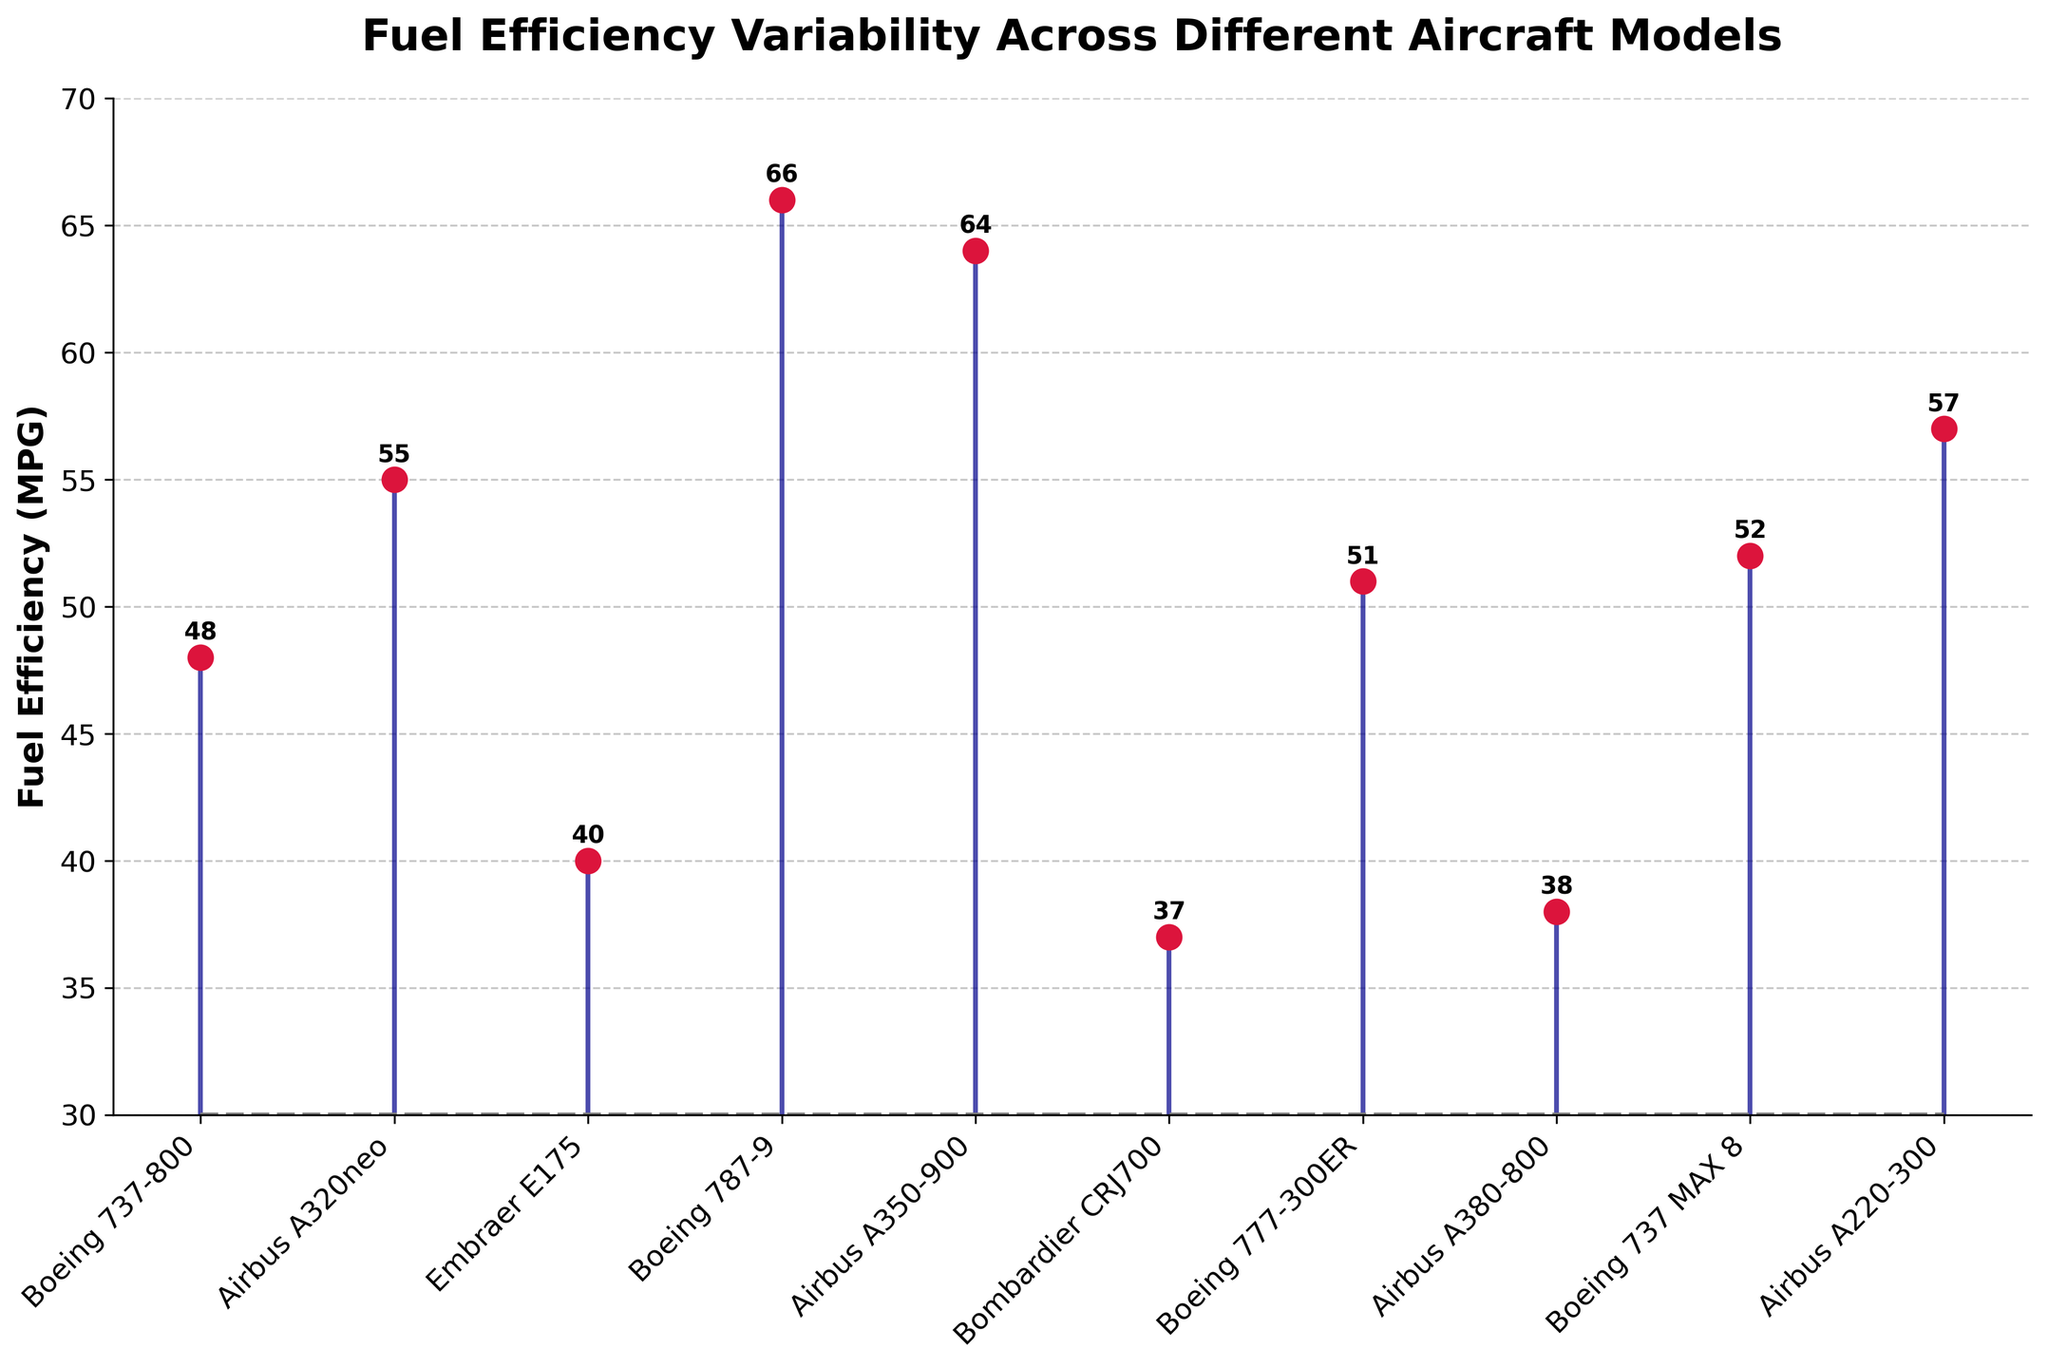What's the title of the stem plot? The title of the stem plot is displayed at the top of the figure in bold. It reads "Fuel Efficiency Variability Across Different Aircraft Models".
Answer: Fuel Efficiency Variability Across Different Aircraft Models How many aircraft models are represented in the plot? By counting the number of stem points on the x-axis, we can see there are ten aircraft models represented in the plot.
Answer: 10 Which aircraft model has the highest fuel efficiency? The highest point on the y-axis indicates the model with the highest fuel efficiency. The "Boeing 787-9" is at the peak with a fuel efficiency of 66 MPG.
Answer: Boeing 787-9 What is the fuel efficiency of the Airbus A320neo? By locating the "Airbus A320neo" on the x-axis and moving vertically to its respective point, we see that its fuel efficiency is 55 MPG.
Answer: 55 Calculate the average fuel efficiency of all the aircraft models. Sum the fuel efficiency of all aircraft models (48 + 55 + 40 + 66 + 64 + 37 + 51 + 38 + 52 + 57) which equals 508, then divide by the number of models (10). The average is 508/10 = 50.8 MPG.
Answer: 50.8 MPG Which aircraft model has a fuel efficiency closest to the average value? First, calculate the average fuel efficiency, which is 50.8 MPG. Then find the model with a value closest to this average. "Boeing 737-800" has a fuel efficiency of 48 MPG, which is closest to 50.8 MPG.
Answer: Boeing 737-800 Compare the fuel efficiencies of the Boeing 777-300ER and Airbus A220-300, which model is more fuel-efficient? Locate the "Boeing 777-300ER" and "Airbus A220-300" on the x-axis and compare their fuel efficiencies. "Boeing 777-300ER" has 51 MPG, whereas "Airbus A220-300" has 57 MPG. The Airbus A220-300 is more fuel-efficient.
Answer: Airbus A220-300 What is the difference in fuel efficiency between the Embraer E175 and the Bombardier CRJ700? Locate both models on the x-axis and note their fuel efficiencies: Embraer E175: 40 MPG, Bombardier CRJ700: 37 MPG. Subtract the fuel efficiency of Bombardier CRJ700 from Embraer E175, which gives 40 - 37 = 3 MPG.
Answer: 3 MPG Identify which data point has the second-lowest fuel efficiency. Order the fuel efficiencies and identify the second-lowest. The lowest is Bombardier CRJ700 with 37 MPG, and the second-lowest is Airbus A380-800 with 38 MPG.
Answer: Airbus A380-800 Is the fuel efficiency of the Boeing 737 MAX 8 greater than or less than the average fuel efficiency of all models? Calculate the average fuel efficiency first (50.8 MPG). The fuel efficiency of the Boeing 737 MAX 8 is 52 MPG. Since 52 is greater than 50.8, the Boeing 737 MAX 8's efficiency is greater than the average.
Answer: Greater 